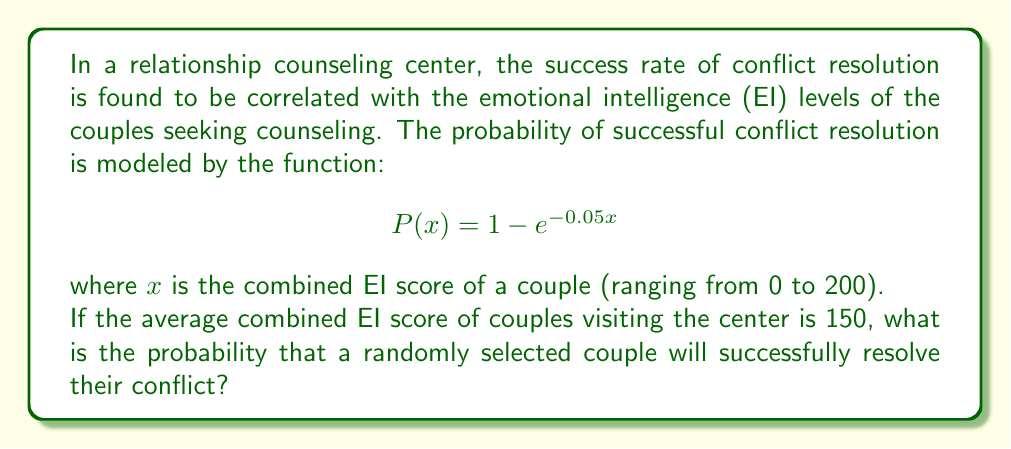Help me with this question. To solve this problem, we need to follow these steps:

1. Understand the given function:
   The probability of successful conflict resolution is given by:
   $$P(x) = 1 - e^{-0.05x}$$
   where $x$ is the combined EI score of a couple.

2. Identify the given information:
   The average combined EI score of couples is 150.

3. Substitute the average EI score into the function:
   $$P(150) = 1 - e^{-0.05(150)}$$

4. Calculate the exponent:
   $$-0.05 * 150 = -7.5$$

5. Simplify the equation:
   $$P(150) = 1 - e^{-7.5}$$

6. Calculate $e^{-7.5}$ using a calculator:
   $$e^{-7.5} \approx 0.00055$$

7. Subtract this value from 1:
   $$P(150) = 1 - 0.00055 \approx 0.99945$$

8. Convert to a percentage:
   $$0.99945 * 100\% \approx 99.945\%$$

This result indicates that for a couple with the average combined EI score of 150, there is a very high probability (approximately 99.945%) of successful conflict resolution.
Answer: The probability that a randomly selected couple will successfully resolve their conflict is approximately 99.945%. 